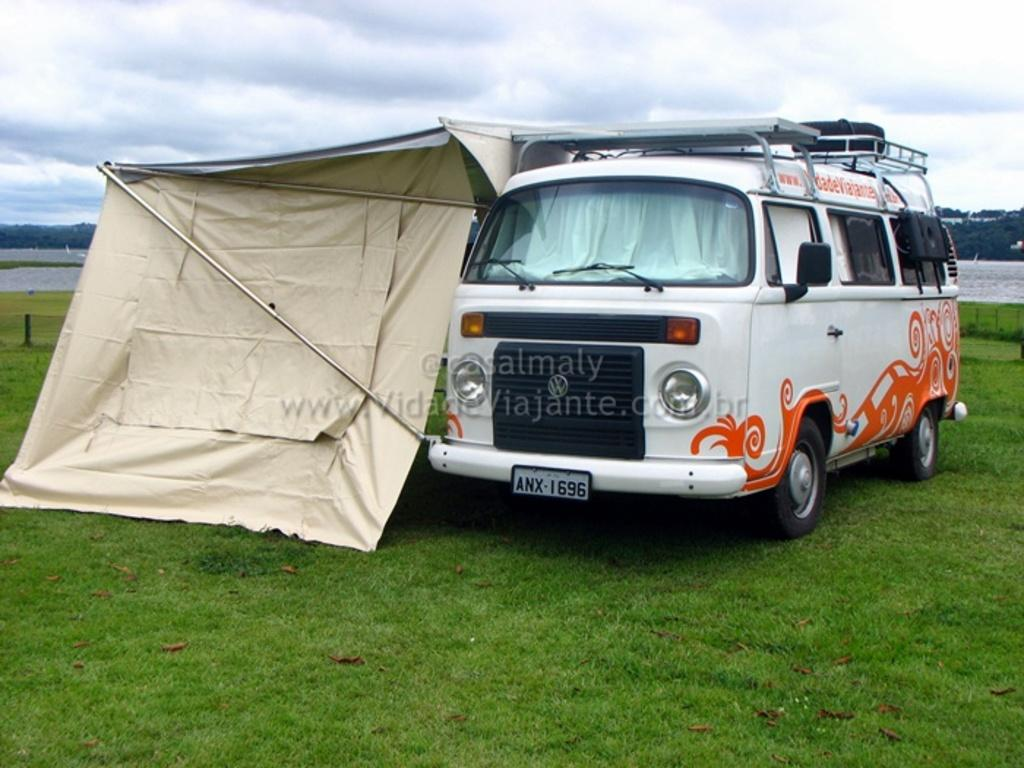What type of terrain is visible in the image? There is grass in the image, indicating a grassy terrain. What type of vehicle is present in the image? There is a vehicle in the image, but its specific type is not mentioned. What type of shelter is present in the image? There is a tent in the image, which can be used for shelter. What are the rods used for in the image? The purpose of the rods in the image is not mentioned, so we cannot determine their use. What is the water feature in the image? There is water in the image, but its specific form (e.g., lake, river, pond) is not mentioned. What type of vegetation is present in the image? There are trees in the image, indicating the presence of trees. What is the pole used for in the image? The purpose of the pole in the image is not mentioned, so we cannot determine its use. What is visible in the background of the image? The sky is visible in the background of the image, and there are clouds in the sky. What nation is represented by the flock of birds in the image? There are no birds present in the image, so we cannot determine which nation they might represent. 